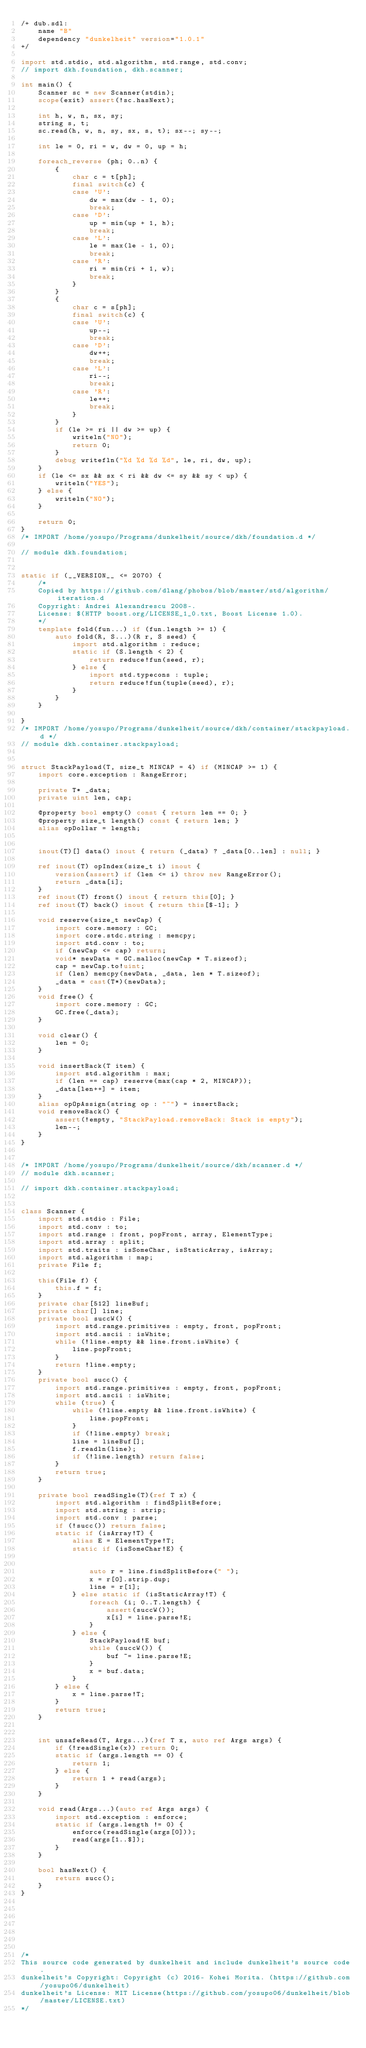Convert code to text. <code><loc_0><loc_0><loc_500><loc_500><_D_>/+ dub.sdl:
    name "B"
    dependency "dunkelheit" version="1.0.1"
+/

import std.stdio, std.algorithm, std.range, std.conv;
// import dkh.foundation, dkh.scanner;

int main() {
    Scanner sc = new Scanner(stdin);
    scope(exit) assert(!sc.hasNext);

    int h, w, n, sx, sy;
    string s, t;
    sc.read(h, w, n, sy, sx, s, t); sx--; sy--;

    int le = 0, ri = w, dw = 0, up = h;

    foreach_reverse (ph; 0..n) {
        {
            char c = t[ph];
            final switch(c) {
            case 'U':
                dw = max(dw - 1, 0);
                break;
            case 'D':
                up = min(up + 1, h);
                break;
            case 'L':
                le = max(le - 1, 0);
                break;
            case 'R':
                ri = min(ri + 1, w);
                break;
            }
        }
        {
            char c = s[ph];
            final switch(c) {
            case 'U':
                up--;
                break;
            case 'D':
                dw++;
                break;
            case 'L':
                ri--;
                break;
            case 'R':
                le++;
                break;
            }
        }
        if (le >= ri || dw >= up) {
            writeln("NO");
            return 0;
        }
        debug writefln("%d %d %d %d", le, ri, dw, up);
    }
    if (le <= sx && sx < ri && dw <= sy && sy < up) {
        writeln("YES");
    } else {
        writeln("NO");
    }
    
    return 0;
}
/* IMPORT /home/yosupo/Programs/dunkelheit/source/dkh/foundation.d */
 
// module dkh.foundation;

 
static if (__VERSION__ <= 2070) {
    /*
    Copied by https://github.com/dlang/phobos/blob/master/std/algorithm/iteration.d
    Copyright: Andrei Alexandrescu 2008-.
    License: $(HTTP boost.org/LICENSE_1_0.txt, Boost License 1.0).
    */
    template fold(fun...) if (fun.length >= 1) {
        auto fold(R, S...)(R r, S seed) {
            import std.algorithm : reduce;
            static if (S.length < 2) {
                return reduce!fun(seed, r);
            } else {
                import std.typecons : tuple;
                return reduce!fun(tuple(seed), r);
            }
        }
    }
     
}
/* IMPORT /home/yosupo/Programs/dunkelheit/source/dkh/container/stackpayload.d */
// module dkh.container.stackpayload;

 
struct StackPayload(T, size_t MINCAP = 4) if (MINCAP >= 1) {
    import core.exception : RangeError;

    private T* _data;
    private uint len, cap;

    @property bool empty() const { return len == 0; }
    @property size_t length() const { return len; }
    alias opDollar = length;

     
    inout(T)[] data() inout { return (_data) ? _data[0..len] : null; }
    
    ref inout(T) opIndex(size_t i) inout {
        version(assert) if (len <= i) throw new RangeError();
        return _data[i];
    }  
    ref inout(T) front() inout { return this[0]; }  
    ref inout(T) back() inout { return this[$-1]; }  

    void reserve(size_t newCap) {
        import core.memory : GC;
        import core.stdc.string : memcpy;
        import std.conv : to;
        if (newCap <= cap) return;
        void* newData = GC.malloc(newCap * T.sizeof);
        cap = newCap.to!uint;
        if (len) memcpy(newData, _data, len * T.sizeof);
        _data = cast(T*)(newData);
    }  
    void free() {
        import core.memory : GC;
        GC.free(_data);
    }  
     
    void clear() {
        len = 0;
    }

    void insertBack(T item) {
        import std.algorithm : max;
        if (len == cap) reserve(max(cap * 2, MINCAP));
        _data[len++] = item;
    }  
    alias opOpAssign(string op : "~") = insertBack;  
    void removeBack() {
        assert(!empty, "StackPayload.removeBack: Stack is empty");
        len--;
    }  
}

 
/* IMPORT /home/yosupo/Programs/dunkelheit/source/dkh/scanner.d */
// module dkh.scanner;

// import dkh.container.stackpayload;

 
class Scanner {
    import std.stdio : File;
    import std.conv : to;
    import std.range : front, popFront, array, ElementType;
    import std.array : split;
    import std.traits : isSomeChar, isStaticArray, isArray; 
    import std.algorithm : map;
    private File f;
     
    this(File f) {
        this.f = f;
    }
    private char[512] lineBuf;
    private char[] line;
    private bool succW() {
        import std.range.primitives : empty, front, popFront;
        import std.ascii : isWhite;
        while (!line.empty && line.front.isWhite) {
            line.popFront;
        }
        return !line.empty;
    }
    private bool succ() {
        import std.range.primitives : empty, front, popFront;
        import std.ascii : isWhite;
        while (true) {
            while (!line.empty && line.front.isWhite) {
                line.popFront;
            }
            if (!line.empty) break;
            line = lineBuf[];
            f.readln(line);
            if (!line.length) return false;
        }
        return true;
    }

    private bool readSingle(T)(ref T x) {
        import std.algorithm : findSplitBefore;
        import std.string : strip;
        import std.conv : parse;
        if (!succ()) return false;
        static if (isArray!T) {
            alias E = ElementType!T;
            static if (isSomeChar!E) {
                 
                 
                auto r = line.findSplitBefore(" ");
                x = r[0].strip.dup;
                line = r[1];
            } else static if (isStaticArray!T) {
                foreach (i; 0..T.length) {
                    assert(succW());
                    x[i] = line.parse!E;
                }
            } else {
                StackPayload!E buf;
                while (succW()) {
                    buf ~= line.parse!E;
                }
                x = buf.data;
            }
        } else {
            x = line.parse!T;
        }
        return true;
    }

     
    int unsafeRead(T, Args...)(ref T x, auto ref Args args) {
        if (!readSingle(x)) return 0;
        static if (args.length == 0) {
            return 1;
        } else {
            return 1 + read(args);
        }
    }
     
    void read(Args...)(auto ref Args args) {
        import std.exception : enforce;
        static if (args.length != 0) {
            enforce(readSingle(args[0]));
            read(args[1..$]);
        }
    }
     
    bool hasNext() {
        return succ();
    }
}


 
 

 

/*
This source code generated by dunkelheit and include dunkelheit's source code.
dunkelheit's Copyright: Copyright (c) 2016- Kohei Morita. (https://github.com/yosupo06/dunkelheit)
dunkelheit's License: MIT License(https://github.com/yosupo06/dunkelheit/blob/master/LICENSE.txt)
*/
</code> 